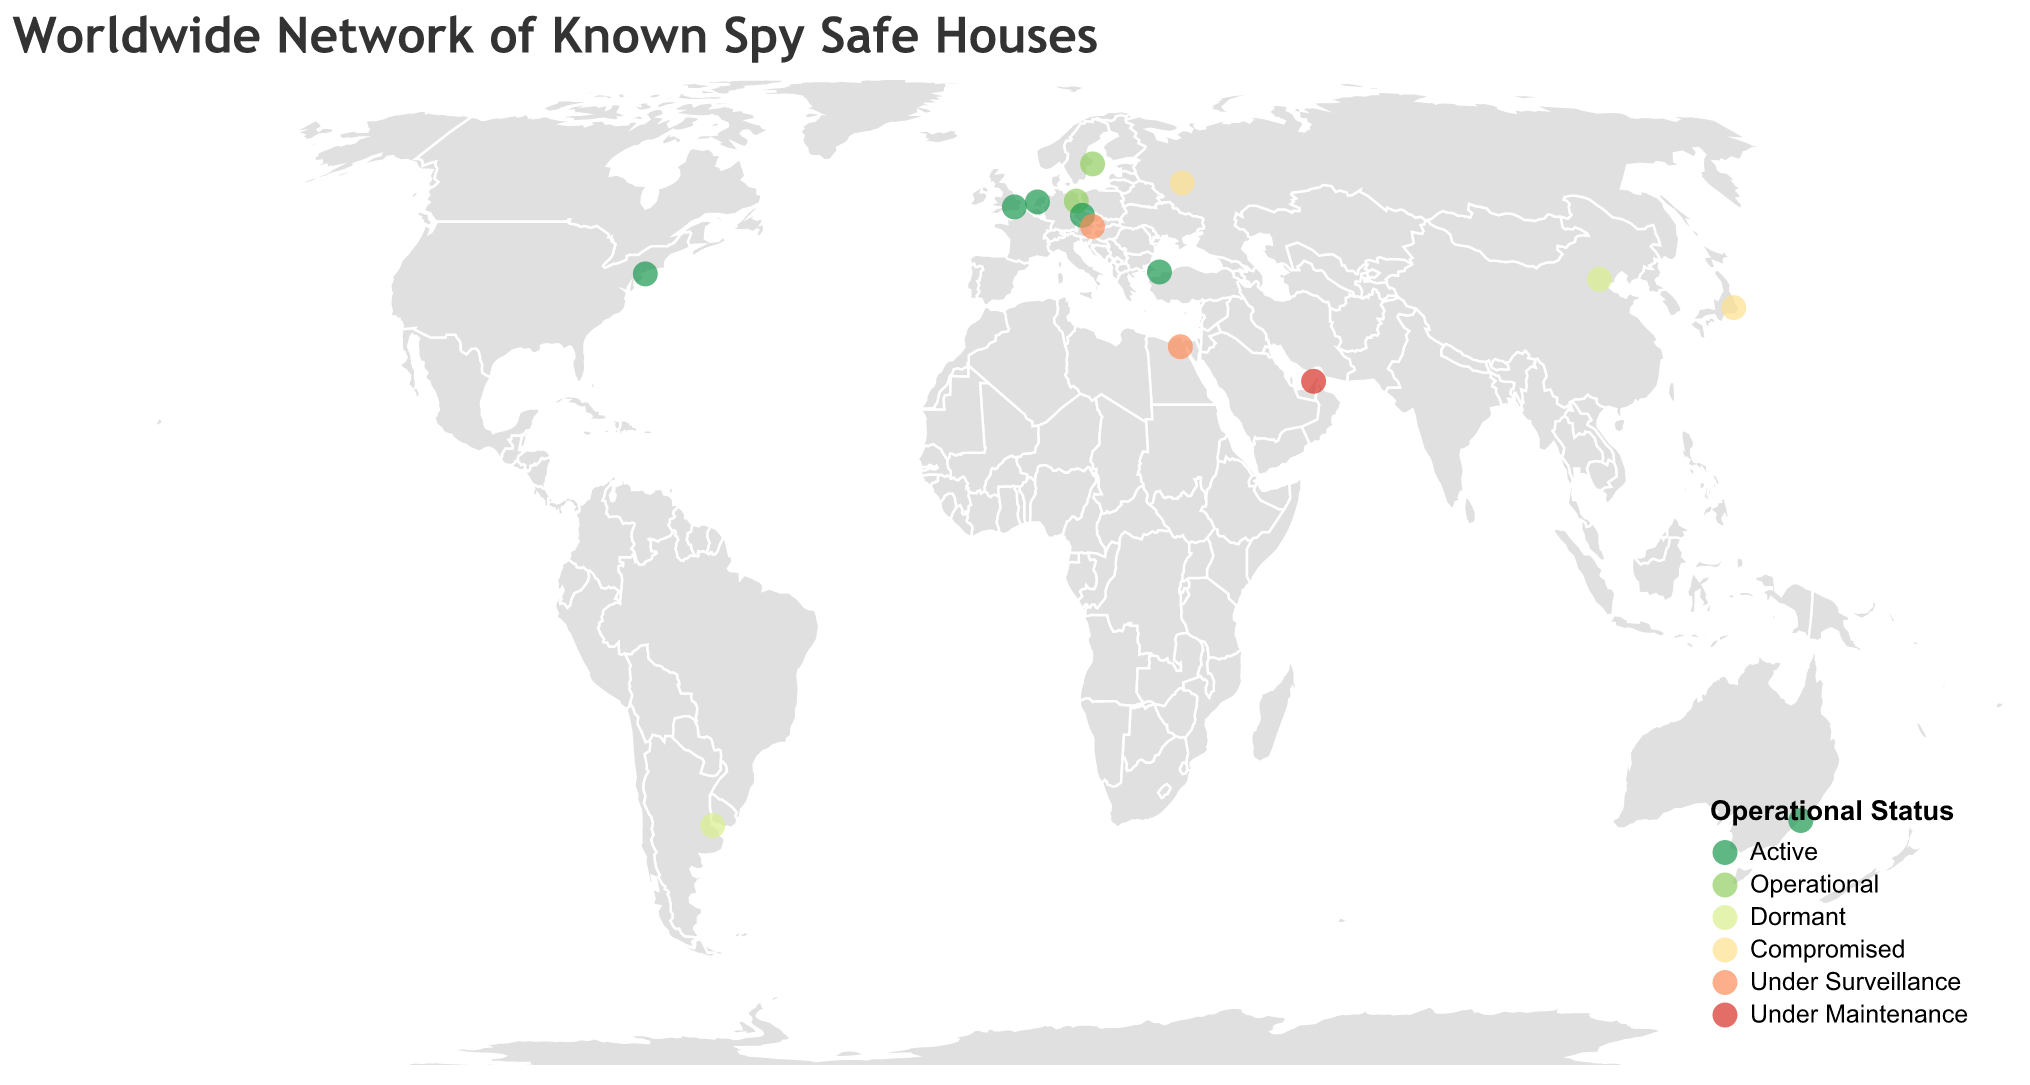What's the title of the figure? The title of the figure is generally located at the top of the visualization and clearly indicates the subject matter.
Answer: Worldwide Network of Known Spy Safe Houses How many safe houses are shown on the map? Each point or circle on the map represents a safe house. By counting all the circles, we determine how many there are.
Answer: 14 Which city has a safe house that is currently marked as "Under Maintenance"? By looking at the color coding for "Under Maintenance" and locating the corresponding circle on the map, we can identify the city.
Answer: Dubai Which operational status has the most safe houses? By examining the map and counting the instances of each color representing the operational statuses, we find the most frequent one.
Answer: Active Which city has a safe house affiliated with the Mossad agency? Using the tooltip or legend to match the agency affiliation, we can locate the specific circle on the map representing Mossad.
Answer: Beijing Are there more safe houses in Europe or Asia? Identify which cities are in Europe and which are in Asia and count the number of safe houses in each region.
Answer: Europe What is the operational status of the safe house in Moscow? Locate Moscow on the map and refer to the color of the circle to determine its operational status.
Answer: Compromised Which agency has the highest number of safe houses marked "Active"? Look at the circles marked "Active" and check their tooltip or color, then count the agency affiliations among them.
Answer: No single agency; four agencies each have one How many cities have safe houses classified as either "Under Surveillance" or "Under Maintenance"? Count the number of circles colored for "Under Surveillance" and "Under Maintenance" statuses combined.
Answer: 3 Which cities have their safe houses compromised? Locate the circles with the color representing "Compromised" and read the tooltips or hover over them to find the cities.
Answer: Moscow, Tokyo 